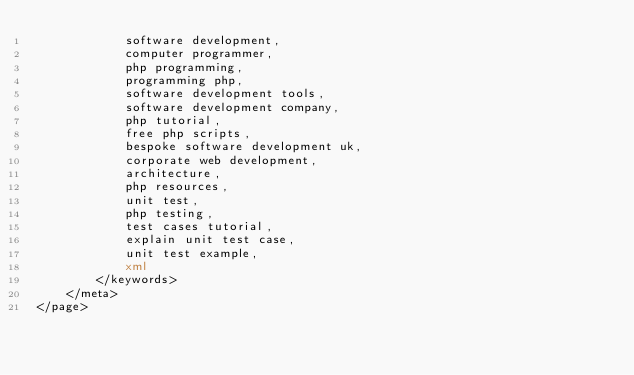<code> <loc_0><loc_0><loc_500><loc_500><_XML_>            software development,
            computer programmer,
            php programming,
            programming php,
            software development tools,
            software development company,
            php tutorial,
            free php scripts,
            bespoke software development uk,
            corporate web development,
            architecture,
            php resources,
            unit test,
            php testing,
            test cases tutorial,
            explain unit test case,
            unit test example,
            xml
        </keywords>
    </meta>
</page></code> 